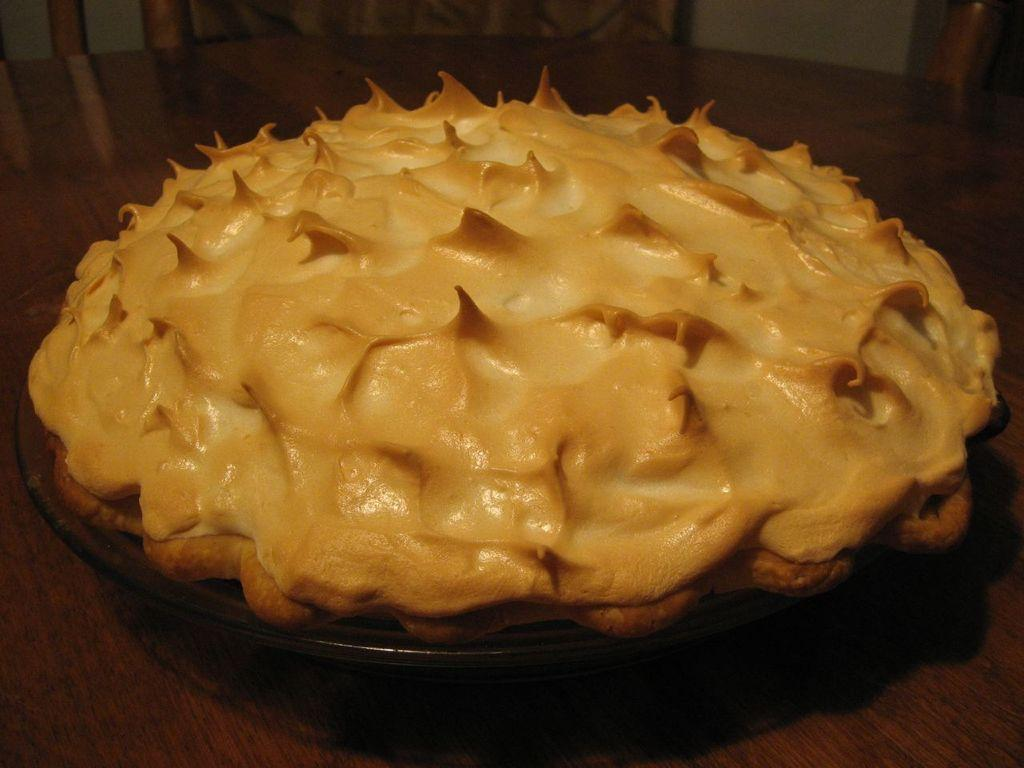What is the main subject of the image? There is a cake in the image. How is the cake positioned in the image? The cake is on a plate. Where is the cake and plate located? The cake and plate are on a table. What can be seen in the background of the image? There is a wall visible in the background of the image, and there are wooden objects present as well. What type of action is the governor taking with the crate in the image? There is no governor or crate present in the image; it features a cake on a plate on a table with a wall and wooden objects in the background. 